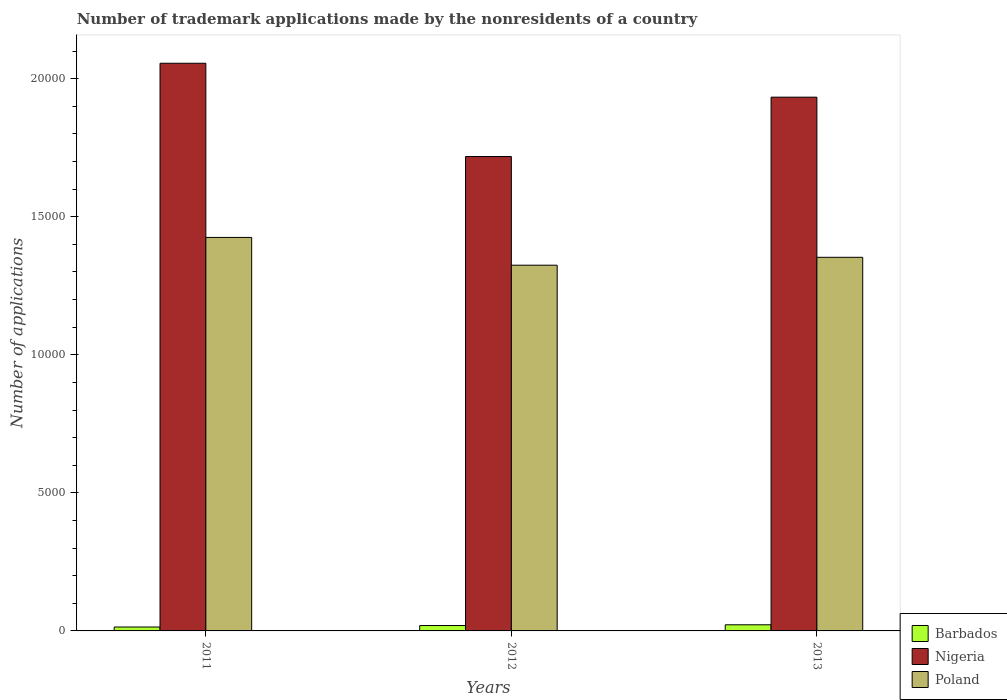How many different coloured bars are there?
Your answer should be very brief. 3. How many bars are there on the 1st tick from the left?
Provide a short and direct response. 3. How many bars are there on the 1st tick from the right?
Provide a short and direct response. 3. What is the label of the 1st group of bars from the left?
Provide a succinct answer. 2011. In how many cases, is the number of bars for a given year not equal to the number of legend labels?
Your answer should be compact. 0. What is the number of trademark applications made by the nonresidents in Poland in 2013?
Provide a succinct answer. 1.35e+04. Across all years, what is the maximum number of trademark applications made by the nonresidents in Nigeria?
Offer a very short reply. 2.06e+04. Across all years, what is the minimum number of trademark applications made by the nonresidents in Nigeria?
Ensure brevity in your answer.  1.72e+04. In which year was the number of trademark applications made by the nonresidents in Nigeria maximum?
Your answer should be very brief. 2011. In which year was the number of trademark applications made by the nonresidents in Poland minimum?
Your answer should be very brief. 2012. What is the total number of trademark applications made by the nonresidents in Barbados in the graph?
Ensure brevity in your answer.  559. What is the difference between the number of trademark applications made by the nonresidents in Poland in 2011 and the number of trademark applications made by the nonresidents in Nigeria in 2013?
Your answer should be very brief. -5080. What is the average number of trademark applications made by the nonresidents in Poland per year?
Your answer should be very brief. 1.37e+04. In the year 2012, what is the difference between the number of trademark applications made by the nonresidents in Nigeria and number of trademark applications made by the nonresidents in Poland?
Offer a terse response. 3936. In how many years, is the number of trademark applications made by the nonresidents in Poland greater than 1000?
Keep it short and to the point. 3. What is the ratio of the number of trademark applications made by the nonresidents in Barbados in 2012 to that in 2013?
Make the answer very short. 0.88. What is the difference between the highest and the second highest number of trademark applications made by the nonresidents in Poland?
Offer a terse response. 720. What does the 1st bar from the left in 2011 represents?
Give a very brief answer. Barbados. Is it the case that in every year, the sum of the number of trademark applications made by the nonresidents in Nigeria and number of trademark applications made by the nonresidents in Barbados is greater than the number of trademark applications made by the nonresidents in Poland?
Make the answer very short. Yes. Does the graph contain any zero values?
Your answer should be compact. No. Does the graph contain grids?
Offer a terse response. No. What is the title of the graph?
Offer a terse response. Number of trademark applications made by the nonresidents of a country. Does "Lesotho" appear as one of the legend labels in the graph?
Ensure brevity in your answer.  No. What is the label or title of the X-axis?
Give a very brief answer. Years. What is the label or title of the Y-axis?
Keep it short and to the point. Number of applications. What is the Number of applications in Barbados in 2011?
Keep it short and to the point. 142. What is the Number of applications in Nigeria in 2011?
Your response must be concise. 2.06e+04. What is the Number of applications in Poland in 2011?
Provide a succinct answer. 1.43e+04. What is the Number of applications of Barbados in 2012?
Offer a very short reply. 195. What is the Number of applications in Nigeria in 2012?
Offer a terse response. 1.72e+04. What is the Number of applications of Poland in 2012?
Provide a short and direct response. 1.32e+04. What is the Number of applications of Barbados in 2013?
Ensure brevity in your answer.  222. What is the Number of applications of Nigeria in 2013?
Ensure brevity in your answer.  1.93e+04. What is the Number of applications in Poland in 2013?
Your answer should be compact. 1.35e+04. Across all years, what is the maximum Number of applications of Barbados?
Give a very brief answer. 222. Across all years, what is the maximum Number of applications in Nigeria?
Provide a succinct answer. 2.06e+04. Across all years, what is the maximum Number of applications in Poland?
Your response must be concise. 1.43e+04. Across all years, what is the minimum Number of applications of Barbados?
Ensure brevity in your answer.  142. Across all years, what is the minimum Number of applications of Nigeria?
Offer a terse response. 1.72e+04. Across all years, what is the minimum Number of applications in Poland?
Your answer should be compact. 1.32e+04. What is the total Number of applications in Barbados in the graph?
Ensure brevity in your answer.  559. What is the total Number of applications in Nigeria in the graph?
Keep it short and to the point. 5.71e+04. What is the total Number of applications of Poland in the graph?
Give a very brief answer. 4.10e+04. What is the difference between the Number of applications of Barbados in 2011 and that in 2012?
Offer a very short reply. -53. What is the difference between the Number of applications of Nigeria in 2011 and that in 2012?
Provide a succinct answer. 3378. What is the difference between the Number of applications of Poland in 2011 and that in 2012?
Give a very brief answer. 1006. What is the difference between the Number of applications in Barbados in 2011 and that in 2013?
Offer a terse response. -80. What is the difference between the Number of applications of Nigeria in 2011 and that in 2013?
Give a very brief answer. 1228. What is the difference between the Number of applications in Poland in 2011 and that in 2013?
Provide a succinct answer. 720. What is the difference between the Number of applications in Barbados in 2012 and that in 2013?
Offer a very short reply. -27. What is the difference between the Number of applications in Nigeria in 2012 and that in 2013?
Offer a terse response. -2150. What is the difference between the Number of applications in Poland in 2012 and that in 2013?
Keep it short and to the point. -286. What is the difference between the Number of applications in Barbados in 2011 and the Number of applications in Nigeria in 2012?
Make the answer very short. -1.70e+04. What is the difference between the Number of applications in Barbados in 2011 and the Number of applications in Poland in 2012?
Your answer should be compact. -1.31e+04. What is the difference between the Number of applications in Nigeria in 2011 and the Number of applications in Poland in 2012?
Keep it short and to the point. 7314. What is the difference between the Number of applications in Barbados in 2011 and the Number of applications in Nigeria in 2013?
Your answer should be very brief. -1.92e+04. What is the difference between the Number of applications of Barbados in 2011 and the Number of applications of Poland in 2013?
Provide a short and direct response. -1.34e+04. What is the difference between the Number of applications of Nigeria in 2011 and the Number of applications of Poland in 2013?
Provide a short and direct response. 7028. What is the difference between the Number of applications in Barbados in 2012 and the Number of applications in Nigeria in 2013?
Offer a very short reply. -1.91e+04. What is the difference between the Number of applications in Barbados in 2012 and the Number of applications in Poland in 2013?
Provide a succinct answer. -1.33e+04. What is the difference between the Number of applications in Nigeria in 2012 and the Number of applications in Poland in 2013?
Offer a very short reply. 3650. What is the average Number of applications of Barbados per year?
Your answer should be compact. 186.33. What is the average Number of applications of Nigeria per year?
Ensure brevity in your answer.  1.90e+04. What is the average Number of applications of Poland per year?
Provide a succinct answer. 1.37e+04. In the year 2011, what is the difference between the Number of applications in Barbados and Number of applications in Nigeria?
Make the answer very short. -2.04e+04. In the year 2011, what is the difference between the Number of applications in Barbados and Number of applications in Poland?
Make the answer very short. -1.41e+04. In the year 2011, what is the difference between the Number of applications of Nigeria and Number of applications of Poland?
Your answer should be compact. 6308. In the year 2012, what is the difference between the Number of applications in Barbados and Number of applications in Nigeria?
Offer a very short reply. -1.70e+04. In the year 2012, what is the difference between the Number of applications of Barbados and Number of applications of Poland?
Offer a terse response. -1.31e+04. In the year 2012, what is the difference between the Number of applications of Nigeria and Number of applications of Poland?
Your response must be concise. 3936. In the year 2013, what is the difference between the Number of applications of Barbados and Number of applications of Nigeria?
Offer a terse response. -1.91e+04. In the year 2013, what is the difference between the Number of applications of Barbados and Number of applications of Poland?
Provide a short and direct response. -1.33e+04. In the year 2013, what is the difference between the Number of applications of Nigeria and Number of applications of Poland?
Offer a very short reply. 5800. What is the ratio of the Number of applications of Barbados in 2011 to that in 2012?
Ensure brevity in your answer.  0.73. What is the ratio of the Number of applications of Nigeria in 2011 to that in 2012?
Your answer should be very brief. 1.2. What is the ratio of the Number of applications of Poland in 2011 to that in 2012?
Offer a very short reply. 1.08. What is the ratio of the Number of applications of Barbados in 2011 to that in 2013?
Offer a very short reply. 0.64. What is the ratio of the Number of applications in Nigeria in 2011 to that in 2013?
Make the answer very short. 1.06. What is the ratio of the Number of applications of Poland in 2011 to that in 2013?
Provide a succinct answer. 1.05. What is the ratio of the Number of applications of Barbados in 2012 to that in 2013?
Offer a very short reply. 0.88. What is the ratio of the Number of applications in Nigeria in 2012 to that in 2013?
Offer a very short reply. 0.89. What is the ratio of the Number of applications in Poland in 2012 to that in 2013?
Offer a very short reply. 0.98. What is the difference between the highest and the second highest Number of applications in Barbados?
Provide a short and direct response. 27. What is the difference between the highest and the second highest Number of applications in Nigeria?
Ensure brevity in your answer.  1228. What is the difference between the highest and the second highest Number of applications of Poland?
Provide a succinct answer. 720. What is the difference between the highest and the lowest Number of applications in Barbados?
Offer a terse response. 80. What is the difference between the highest and the lowest Number of applications in Nigeria?
Offer a terse response. 3378. What is the difference between the highest and the lowest Number of applications of Poland?
Keep it short and to the point. 1006. 